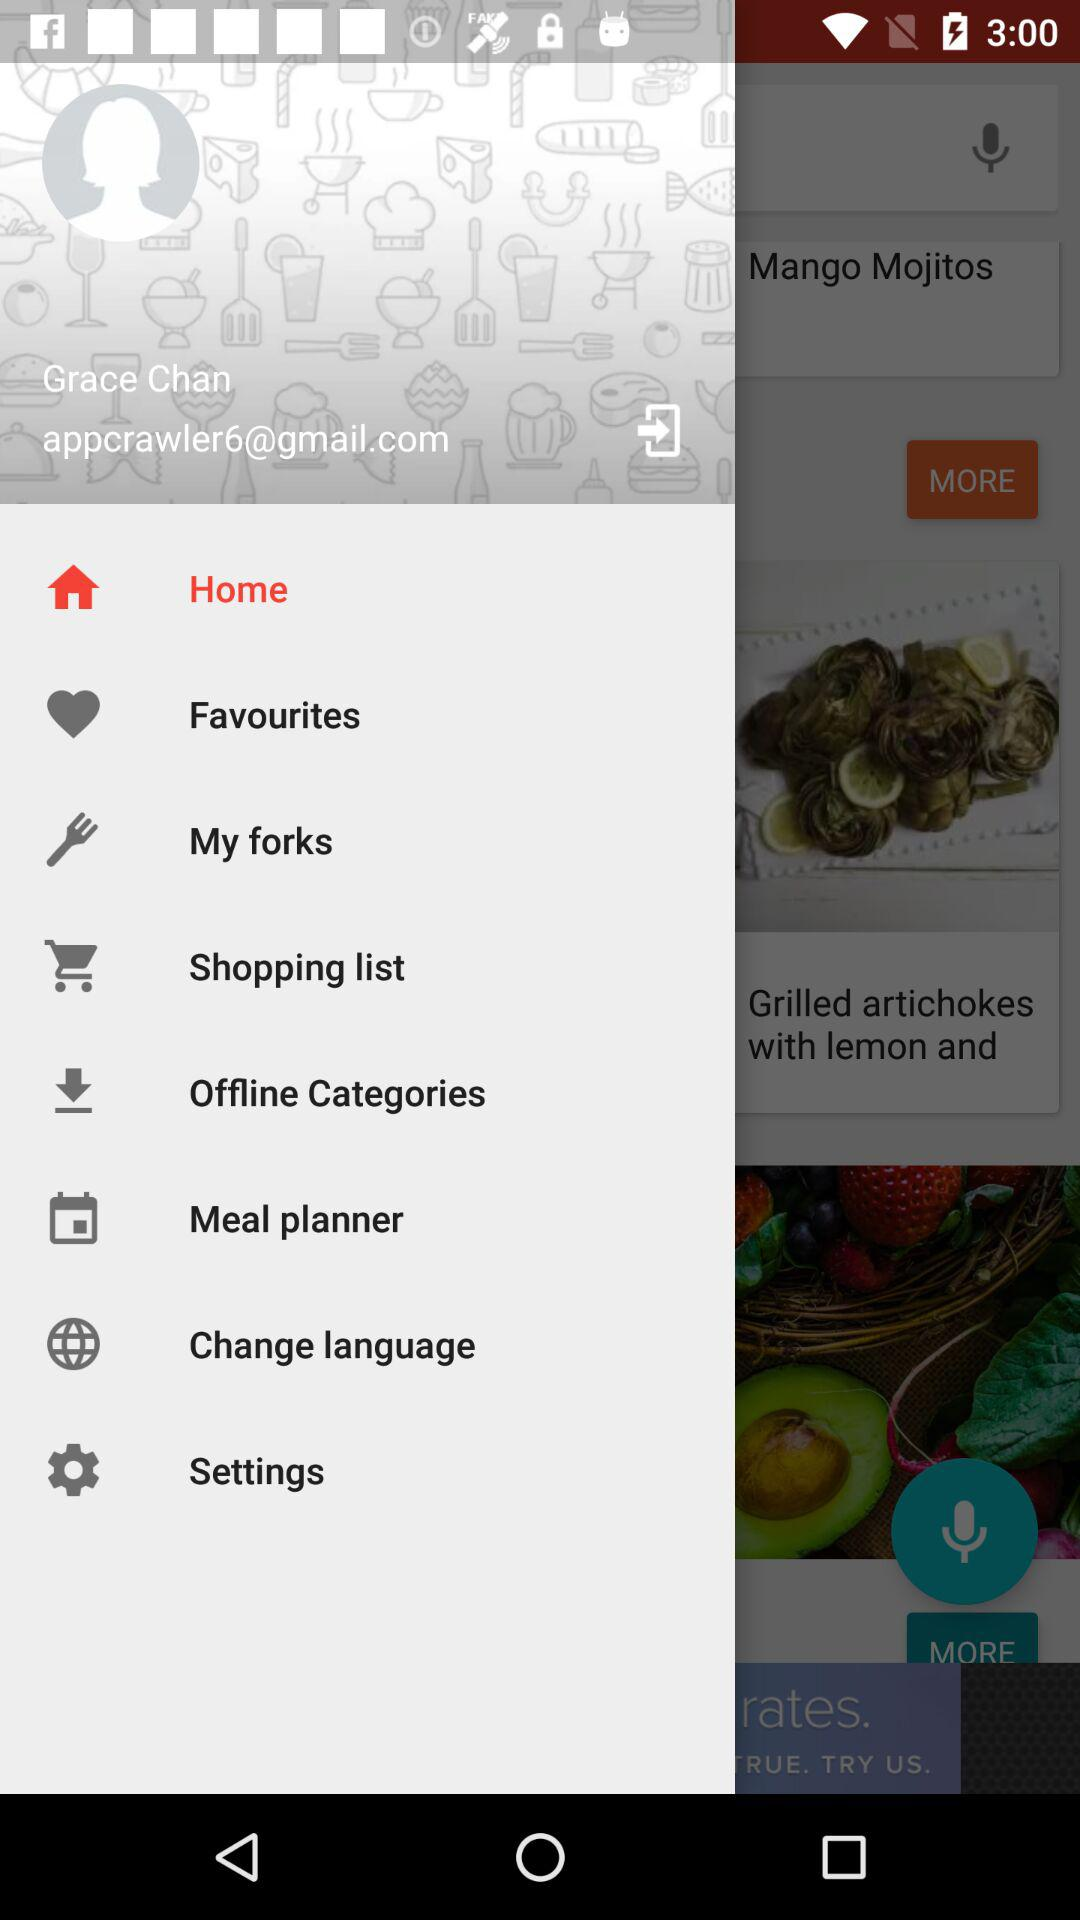What is the name of the user? The name of the user is Grace Chan. 